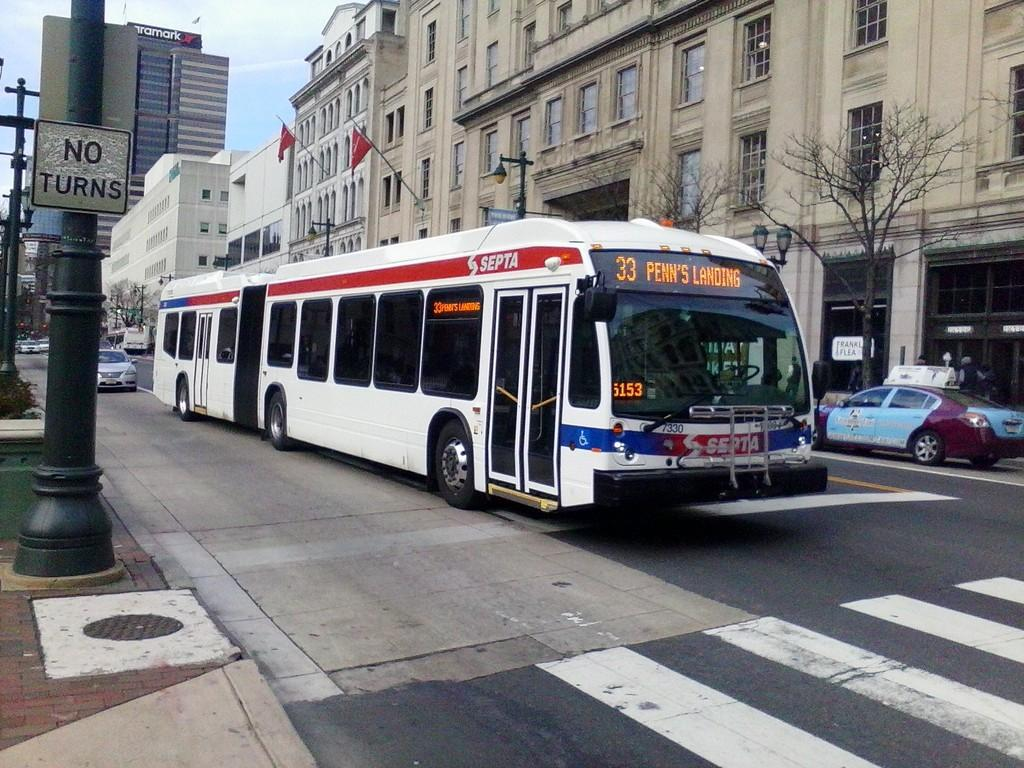What can be seen on the road in the image? There are vehicles on the road in the image. What is located on the left side of the vehicles? There are poles on the left side of the vehicles. What is on the right side of the vehicles? There are trees and buildings on the right side of the vehicles. What is visible in the background of the image? The sky is visible in the image. How many elbows can be seen in the image? There are no elbows visible in the image. What type of stick is being used by the trees in the image? There are no sticks being used by the trees in the image; they are natural trees. 